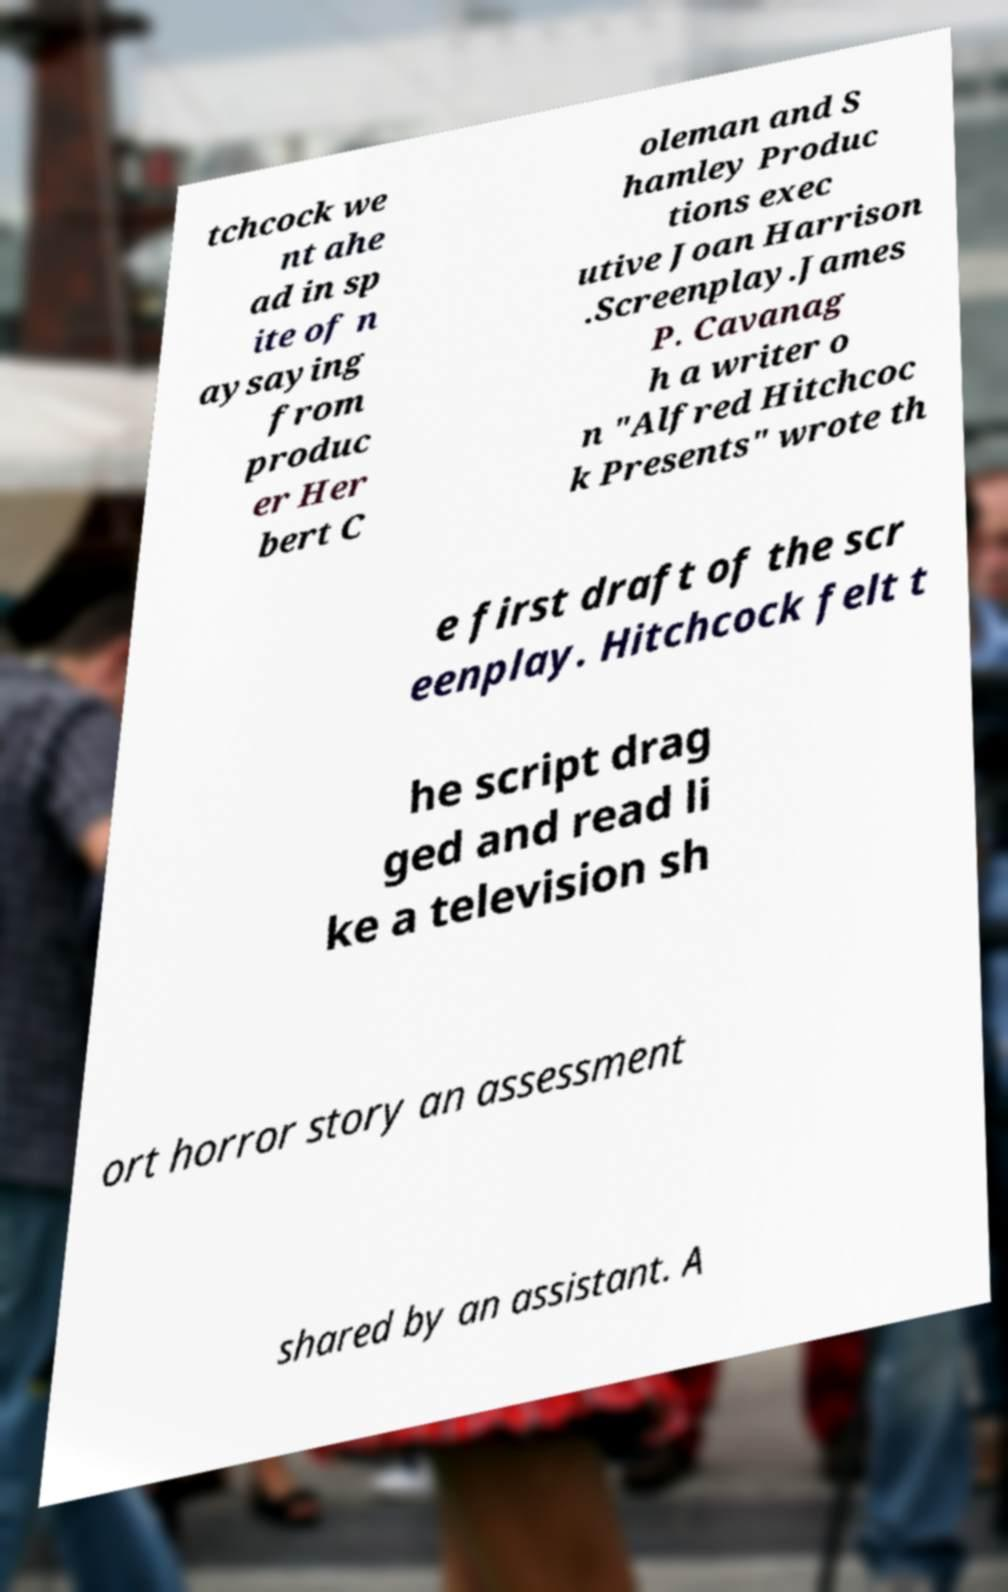What messages or text are displayed in this image? I need them in a readable, typed format. tchcock we nt ahe ad in sp ite of n aysaying from produc er Her bert C oleman and S hamley Produc tions exec utive Joan Harrison .Screenplay.James P. Cavanag h a writer o n "Alfred Hitchcoc k Presents" wrote th e first draft of the scr eenplay. Hitchcock felt t he script drag ged and read li ke a television sh ort horror story an assessment shared by an assistant. A 